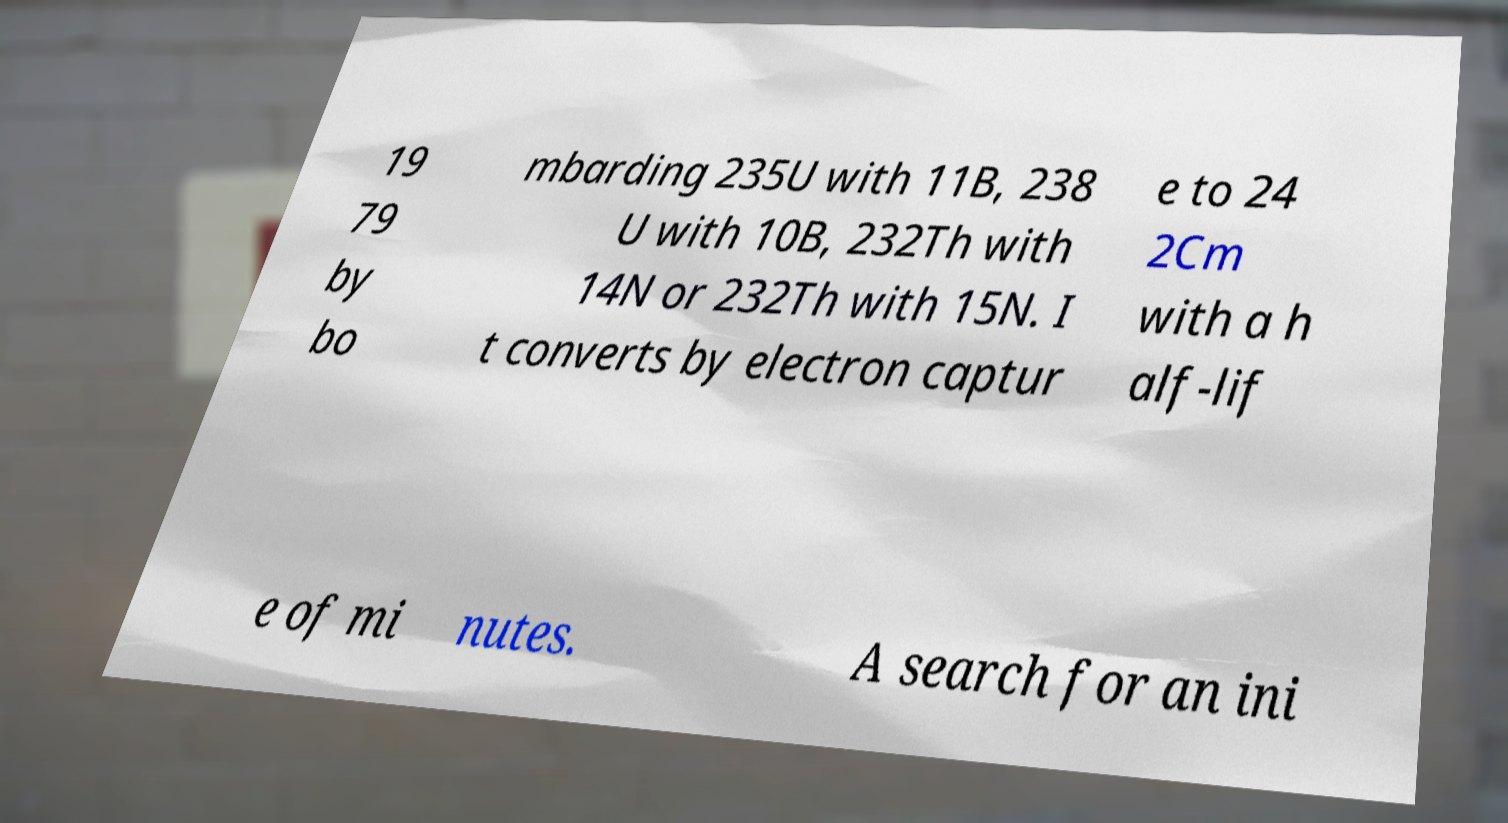What messages or text are displayed in this image? I need them in a readable, typed format. 19 79 by bo mbarding 235U with 11B, 238 U with 10B, 232Th with 14N or 232Th with 15N. I t converts by electron captur e to 24 2Cm with a h alf-lif e of mi nutes. A search for an ini 